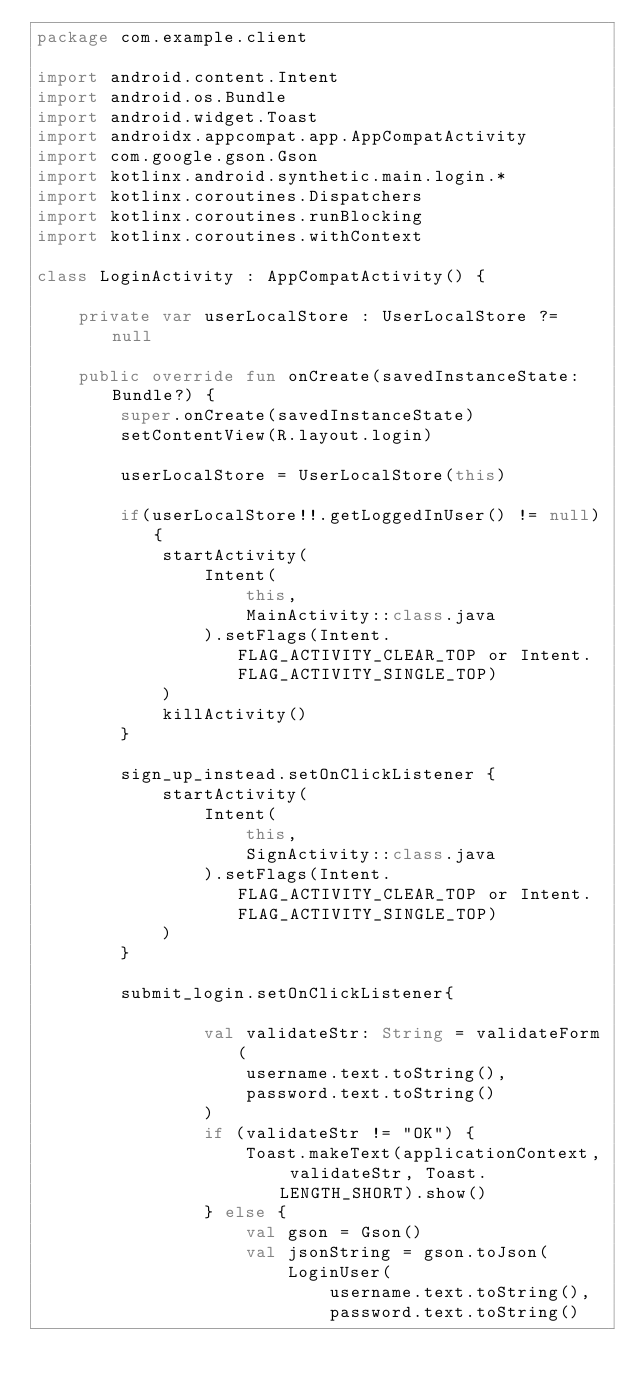Convert code to text. <code><loc_0><loc_0><loc_500><loc_500><_Kotlin_>package com.example.client

import android.content.Intent
import android.os.Bundle
import android.widget.Toast
import androidx.appcompat.app.AppCompatActivity
import com.google.gson.Gson
import kotlinx.android.synthetic.main.login.*
import kotlinx.coroutines.Dispatchers
import kotlinx.coroutines.runBlocking
import kotlinx.coroutines.withContext

class LoginActivity : AppCompatActivity() {

    private var userLocalStore : UserLocalStore ?= null

    public override fun onCreate(savedInstanceState: Bundle?) {
        super.onCreate(savedInstanceState)
        setContentView(R.layout.login)

        userLocalStore = UserLocalStore(this)

        if(userLocalStore!!.getLoggedInUser() != null){
            startActivity(
                Intent(
                    this,
                    MainActivity::class.java
                ).setFlags(Intent.FLAG_ACTIVITY_CLEAR_TOP or Intent.FLAG_ACTIVITY_SINGLE_TOP)
            )
            killActivity()
        }

        sign_up_instead.setOnClickListener {
            startActivity(
                Intent(
                    this,
                    SignActivity::class.java
                ).setFlags(Intent.FLAG_ACTIVITY_CLEAR_TOP or Intent.FLAG_ACTIVITY_SINGLE_TOP)
            )
        }

        submit_login.setOnClickListener{

                val validateStr: String = validateForm(
                    username.text.toString(),
                    password.text.toString()
                )
                if (validateStr != "OK") {
                    Toast.makeText(applicationContext, validateStr, Toast.LENGTH_SHORT).show()
                } else {
                    val gson = Gson()
                    val jsonString = gson.toJson(
                        LoginUser(
                            username.text.toString(),
                            password.text.toString()</code> 